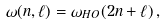<formula> <loc_0><loc_0><loc_500><loc_500>\omega ( n , \ell ) = \omega _ { H O } ( 2 n + \ell ) \, ,</formula> 